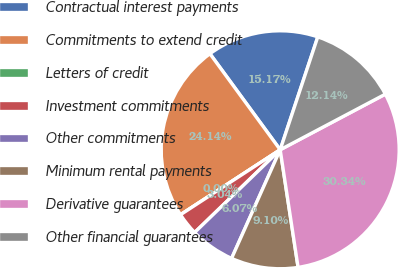<chart> <loc_0><loc_0><loc_500><loc_500><pie_chart><fcel>Contractual interest payments<fcel>Commitments to extend credit<fcel>Letters of credit<fcel>Investment commitments<fcel>Other commitments<fcel>Minimum rental payments<fcel>Derivative guarantees<fcel>Other financial guarantees<nl><fcel>15.17%<fcel>24.14%<fcel>0.0%<fcel>3.04%<fcel>6.07%<fcel>9.1%<fcel>30.34%<fcel>12.14%<nl></chart> 